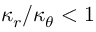<formula> <loc_0><loc_0><loc_500><loc_500>\kappa _ { r } / \kappa _ { \theta } < 1</formula> 